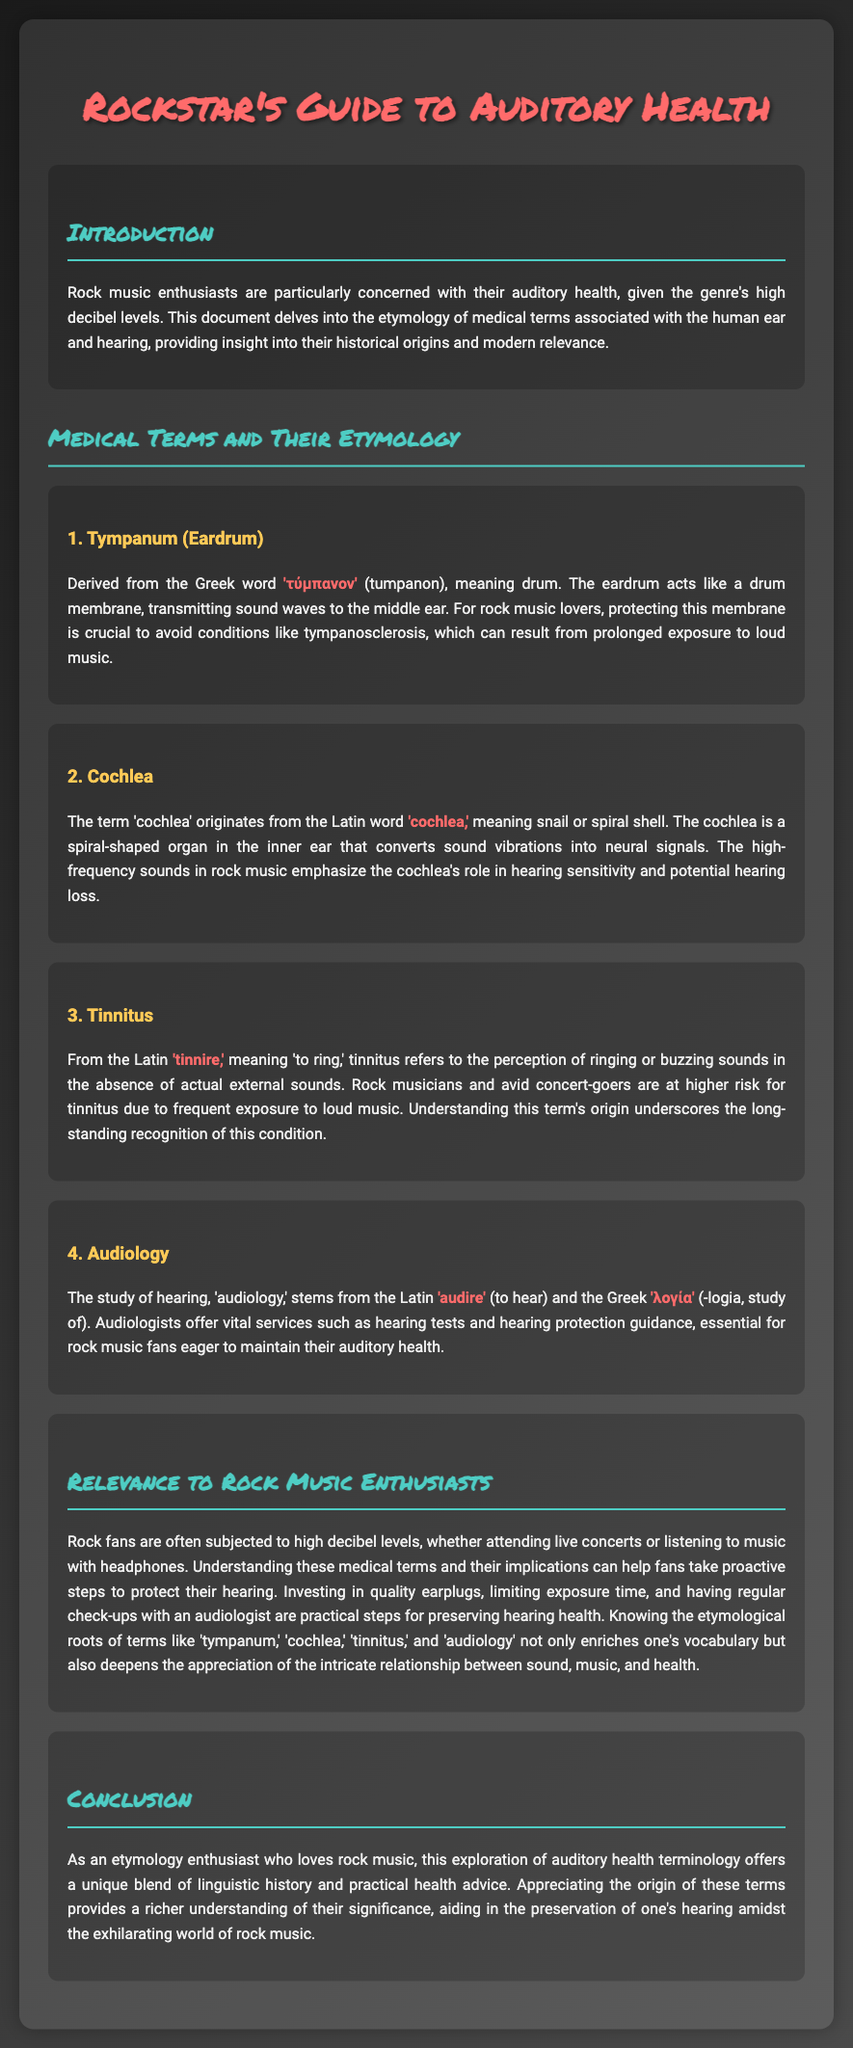What is the title of the document? The title of the document is indicated at the top of the rendered content, which is "Rockstar's Guide to Auditory Health."
Answer: Rockstar's Guide to Auditory Health What does the Greek word 'τύμπανον' mean? The Greek word 'τύμπανον' (tumpanon) means drum, relevant to the eardrum's function.
Answer: Drum What condition can result from prolonged exposure to loud music? The document mentions tympanosclerosis as a condition that can occur due to high decibel levels.
Answer: Tympanosclerosis What is the origin of the word 'tinnitus'? The term 'tinnitus' comes from the Latin word 'tinnire,' which means 'to ring.'
Answer: Tinnire What does the term 'audiology' relate to? The term 'audiology' is the study of hearing, derived from Latin and Greek roots.
Answer: Study of hearing What urgent steps can rock music enthusiasts take to protect their hearing? The document suggests investing in quality earplugs, limiting exposure time, and having regular check-ups with an audiologist.
Answer: Quality earplugs, limit exposure, audiologist check-ups What is the relevance of understanding etymology for rock music fans? Understanding the etymology of terms enriches vocabulary and deepens appreciation for the relationship between sound, music, and health.
Answer: Enriches vocabulary and appreciation Which organ in the inner ear converts sound vibrations into neural signals? The cochlea is identified as the organ responsible for converting sound vibrations in the inner ear.
Answer: Cochlea 